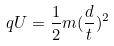Convert formula to latex. <formula><loc_0><loc_0><loc_500><loc_500>q U = \frac { 1 } { 2 } m ( \frac { d } { t } ) ^ { 2 }</formula> 